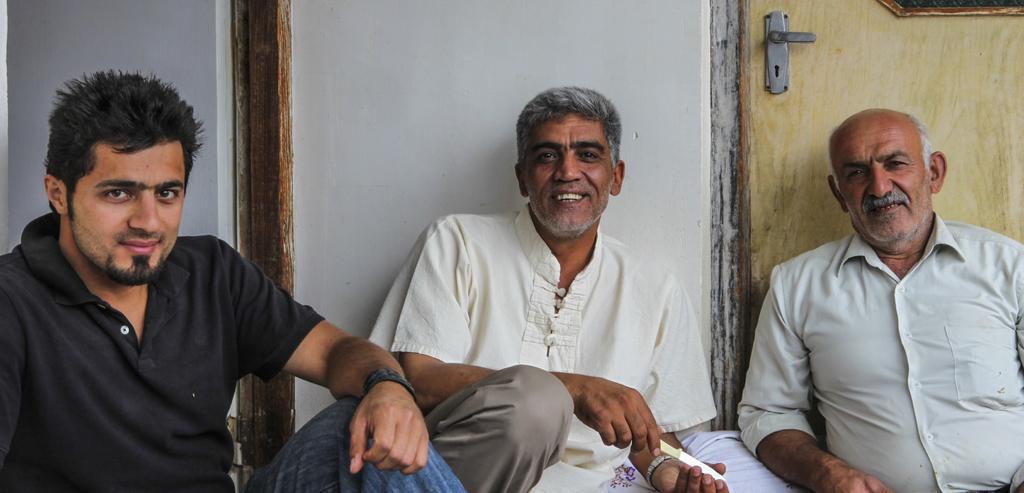Could you give a brief overview of what you see in this image? In the middle of the image three persons are sitting, smiling and he is holding a knife. Behind them we can see a wall and door. 